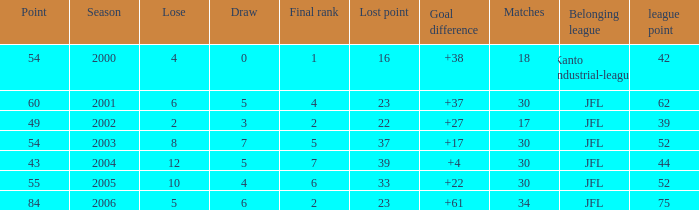Tell me the average final rank for loe more than 10 and point less than 43 None. 